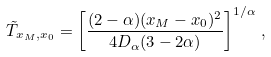Convert formula to latex. <formula><loc_0><loc_0><loc_500><loc_500>\tilde { T } _ { x _ { M } , x _ { 0 } } = \left [ \frac { ( 2 - \alpha ) ( x _ { M } - x _ { 0 } ) ^ { 2 } } { 4 D _ { \alpha } ( 3 - 2 \alpha ) } \right ] ^ { 1 / \alpha } \, ,</formula> 